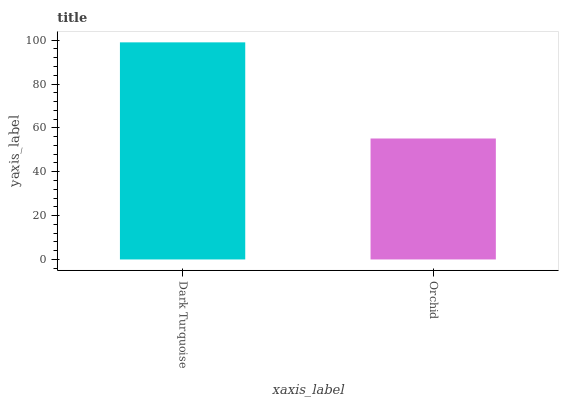Is Orchid the minimum?
Answer yes or no. Yes. Is Dark Turquoise the maximum?
Answer yes or no. Yes. Is Orchid the maximum?
Answer yes or no. No. Is Dark Turquoise greater than Orchid?
Answer yes or no. Yes. Is Orchid less than Dark Turquoise?
Answer yes or no. Yes. Is Orchid greater than Dark Turquoise?
Answer yes or no. No. Is Dark Turquoise less than Orchid?
Answer yes or no. No. Is Dark Turquoise the high median?
Answer yes or no. Yes. Is Orchid the low median?
Answer yes or no. Yes. Is Orchid the high median?
Answer yes or no. No. Is Dark Turquoise the low median?
Answer yes or no. No. 